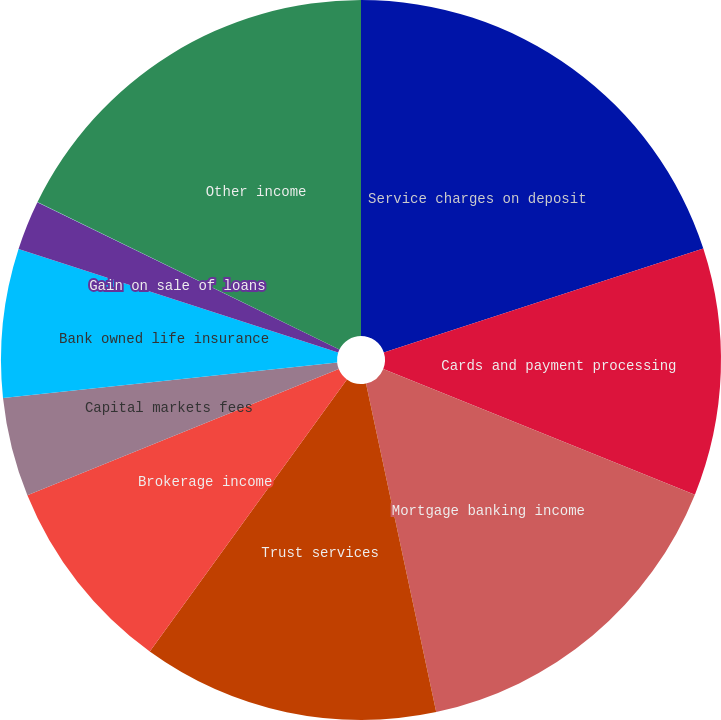<chart> <loc_0><loc_0><loc_500><loc_500><pie_chart><fcel>Service charges on deposit<fcel>Cards and payment processing<fcel>Mortgage banking income<fcel>Trust services<fcel>Brokerage income<fcel>Capital markets fees<fcel>Bank owned life insurance<fcel>Gain on sale of loans<fcel>Securities gains (losses)<fcel>Other income<nl><fcel>19.99%<fcel>11.11%<fcel>15.55%<fcel>13.33%<fcel>8.89%<fcel>4.45%<fcel>6.67%<fcel>2.23%<fcel>0.01%<fcel>17.77%<nl></chart> 